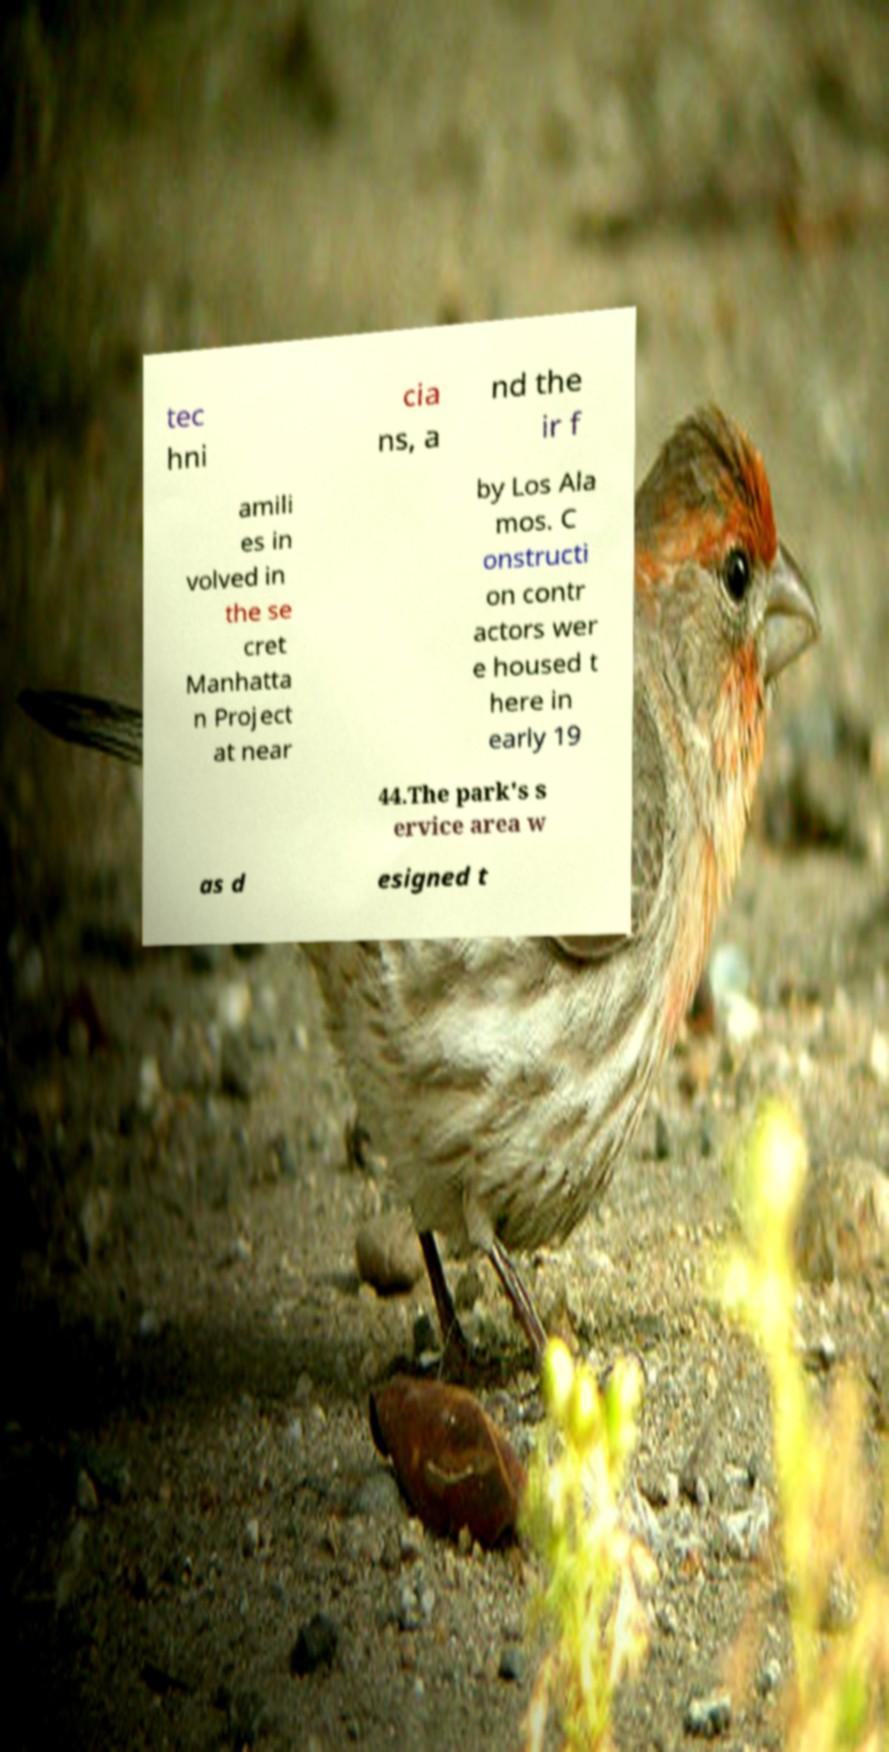Could you extract and type out the text from this image? tec hni cia ns, a nd the ir f amili es in volved in the se cret Manhatta n Project at near by Los Ala mos. C onstructi on contr actors wer e housed t here in early 19 44.The park's s ervice area w as d esigned t 